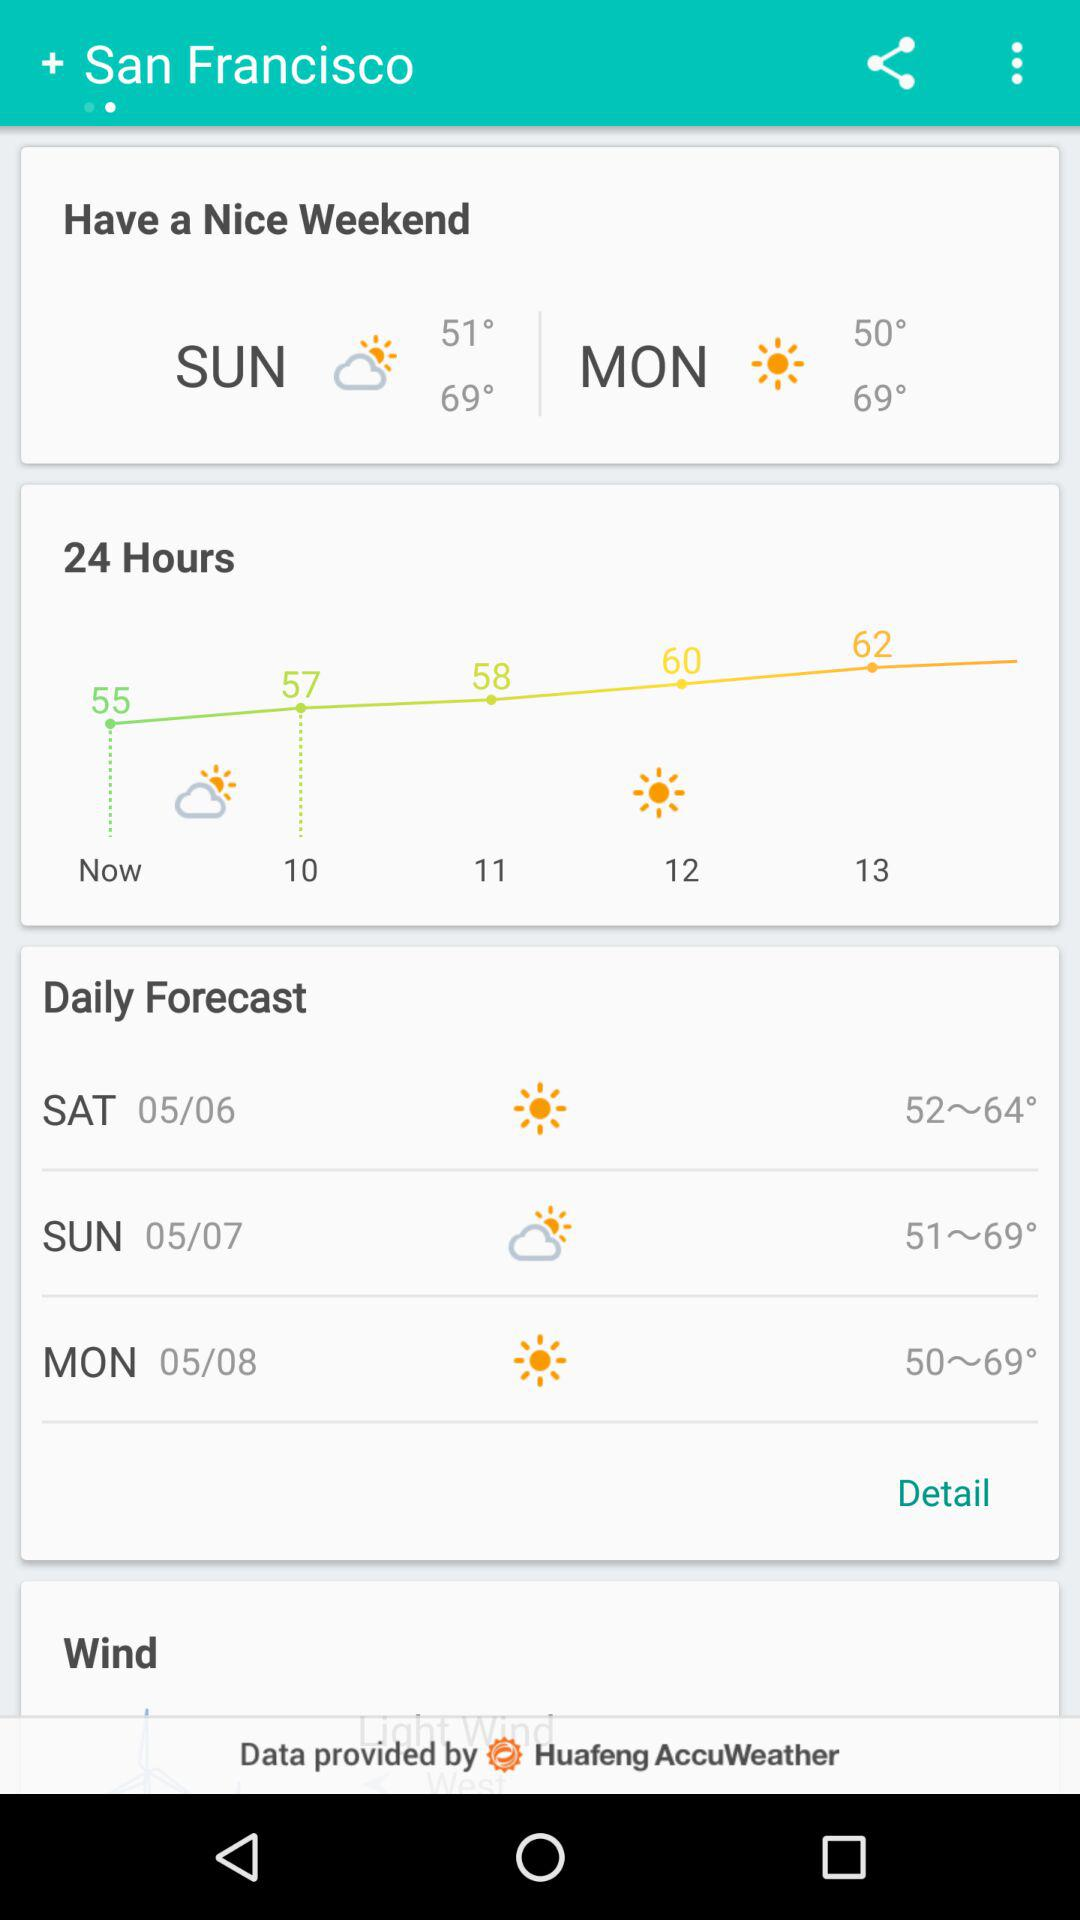How many hours is the weather forecast for?
Answer the question using a single word or phrase. 24 